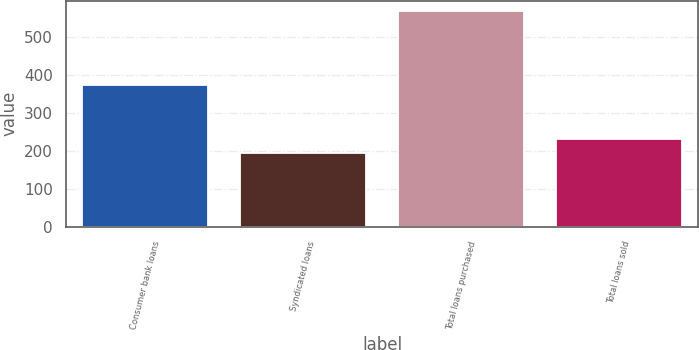Convert chart to OTSL. <chart><loc_0><loc_0><loc_500><loc_500><bar_chart><fcel>Consumer bank loans<fcel>Syndicated loans<fcel>Total loans purchased<fcel>Total loans sold<nl><fcel>373<fcel>194<fcel>567<fcel>231.3<nl></chart> 